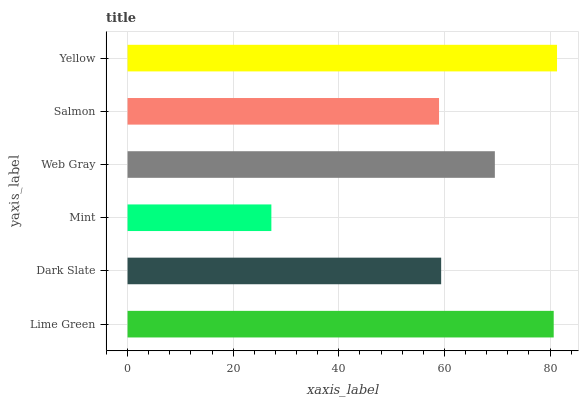Is Mint the minimum?
Answer yes or no. Yes. Is Yellow the maximum?
Answer yes or no. Yes. Is Dark Slate the minimum?
Answer yes or no. No. Is Dark Slate the maximum?
Answer yes or no. No. Is Lime Green greater than Dark Slate?
Answer yes or no. Yes. Is Dark Slate less than Lime Green?
Answer yes or no. Yes. Is Dark Slate greater than Lime Green?
Answer yes or no. No. Is Lime Green less than Dark Slate?
Answer yes or no. No. Is Web Gray the high median?
Answer yes or no. Yes. Is Dark Slate the low median?
Answer yes or no. Yes. Is Salmon the high median?
Answer yes or no. No. Is Salmon the low median?
Answer yes or no. No. 